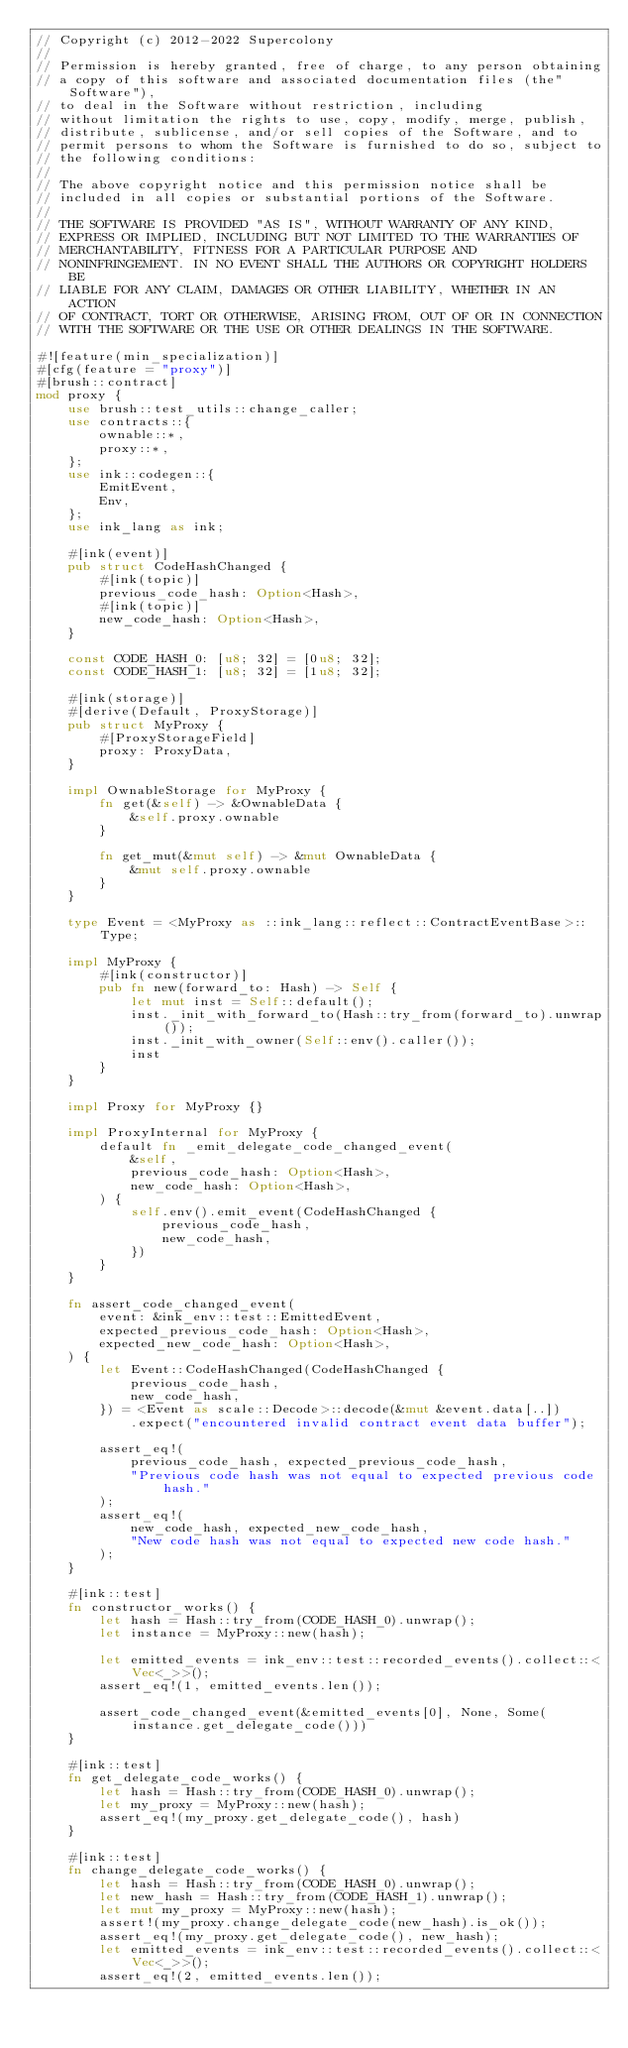<code> <loc_0><loc_0><loc_500><loc_500><_Rust_>// Copyright (c) 2012-2022 Supercolony
//
// Permission is hereby granted, free of charge, to any person obtaining
// a copy of this software and associated documentation files (the"Software"),
// to deal in the Software without restriction, including
// without limitation the rights to use, copy, modify, merge, publish,
// distribute, sublicense, and/or sell copies of the Software, and to
// permit persons to whom the Software is furnished to do so, subject to
// the following conditions:
//
// The above copyright notice and this permission notice shall be
// included in all copies or substantial portions of the Software.
//
// THE SOFTWARE IS PROVIDED "AS IS", WITHOUT WARRANTY OF ANY KIND,
// EXPRESS OR IMPLIED, INCLUDING BUT NOT LIMITED TO THE WARRANTIES OF
// MERCHANTABILITY, FITNESS FOR A PARTICULAR PURPOSE AND
// NONINFRINGEMENT. IN NO EVENT SHALL THE AUTHORS OR COPYRIGHT HOLDERS BE
// LIABLE FOR ANY CLAIM, DAMAGES OR OTHER LIABILITY, WHETHER IN AN ACTION
// OF CONTRACT, TORT OR OTHERWISE, ARISING FROM, OUT OF OR IN CONNECTION
// WITH THE SOFTWARE OR THE USE OR OTHER DEALINGS IN THE SOFTWARE.

#![feature(min_specialization)]
#[cfg(feature = "proxy")]
#[brush::contract]
mod proxy {
    use brush::test_utils::change_caller;
    use contracts::{
        ownable::*,
        proxy::*,
    };
    use ink::codegen::{
        EmitEvent,
        Env,
    };
    use ink_lang as ink;

    #[ink(event)]
    pub struct CodeHashChanged {
        #[ink(topic)]
        previous_code_hash: Option<Hash>,
        #[ink(topic)]
        new_code_hash: Option<Hash>,
    }

    const CODE_HASH_0: [u8; 32] = [0u8; 32];
    const CODE_HASH_1: [u8; 32] = [1u8; 32];

    #[ink(storage)]
    #[derive(Default, ProxyStorage)]
    pub struct MyProxy {
        #[ProxyStorageField]
        proxy: ProxyData,
    }

    impl OwnableStorage for MyProxy {
        fn get(&self) -> &OwnableData {
            &self.proxy.ownable
        }

        fn get_mut(&mut self) -> &mut OwnableData {
            &mut self.proxy.ownable
        }
    }

    type Event = <MyProxy as ::ink_lang::reflect::ContractEventBase>::Type;

    impl MyProxy {
        #[ink(constructor)]
        pub fn new(forward_to: Hash) -> Self {
            let mut inst = Self::default();
            inst._init_with_forward_to(Hash::try_from(forward_to).unwrap());
            inst._init_with_owner(Self::env().caller());
            inst
        }
    }

    impl Proxy for MyProxy {}

    impl ProxyInternal for MyProxy {
        default fn _emit_delegate_code_changed_event(
            &self,
            previous_code_hash: Option<Hash>,
            new_code_hash: Option<Hash>,
        ) {
            self.env().emit_event(CodeHashChanged {
                previous_code_hash,
                new_code_hash,
            })
        }
    }

    fn assert_code_changed_event(
        event: &ink_env::test::EmittedEvent,
        expected_previous_code_hash: Option<Hash>,
        expected_new_code_hash: Option<Hash>,
    ) {
        let Event::CodeHashChanged(CodeHashChanged {
            previous_code_hash,
            new_code_hash,
        }) = <Event as scale::Decode>::decode(&mut &event.data[..])
            .expect("encountered invalid contract event data buffer");

        assert_eq!(
            previous_code_hash, expected_previous_code_hash,
            "Previous code hash was not equal to expected previous code hash."
        );
        assert_eq!(
            new_code_hash, expected_new_code_hash,
            "New code hash was not equal to expected new code hash."
        );
    }

    #[ink::test]
    fn constructor_works() {
        let hash = Hash::try_from(CODE_HASH_0).unwrap();
        let instance = MyProxy::new(hash);

        let emitted_events = ink_env::test::recorded_events().collect::<Vec<_>>();
        assert_eq!(1, emitted_events.len());

        assert_code_changed_event(&emitted_events[0], None, Some(instance.get_delegate_code()))
    }

    #[ink::test]
    fn get_delegate_code_works() {
        let hash = Hash::try_from(CODE_HASH_0).unwrap();
        let my_proxy = MyProxy::new(hash);
        assert_eq!(my_proxy.get_delegate_code(), hash)
    }

    #[ink::test]
    fn change_delegate_code_works() {
        let hash = Hash::try_from(CODE_HASH_0).unwrap();
        let new_hash = Hash::try_from(CODE_HASH_1).unwrap();
        let mut my_proxy = MyProxy::new(hash);
        assert!(my_proxy.change_delegate_code(new_hash).is_ok());
        assert_eq!(my_proxy.get_delegate_code(), new_hash);
        let emitted_events = ink_env::test::recorded_events().collect::<Vec<_>>();
        assert_eq!(2, emitted_events.len());</code> 